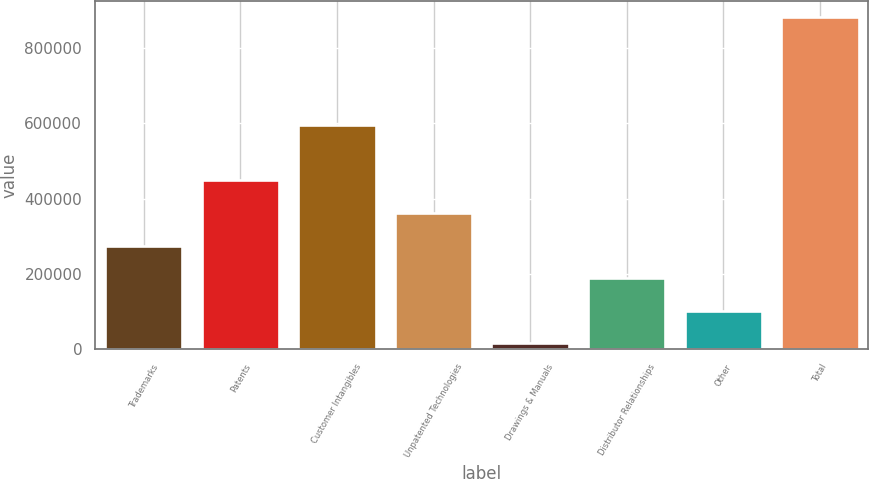Convert chart to OTSL. <chart><loc_0><loc_0><loc_500><loc_500><bar_chart><fcel>Trademarks<fcel>Patents<fcel>Customer Intangibles<fcel>Unpatented Technologies<fcel>Drawings & Manuals<fcel>Distributor Relationships<fcel>Other<fcel>Total<nl><fcel>275513<fcel>448682<fcel>595635<fcel>362097<fcel>15760<fcel>188929<fcel>102344<fcel>881603<nl></chart> 